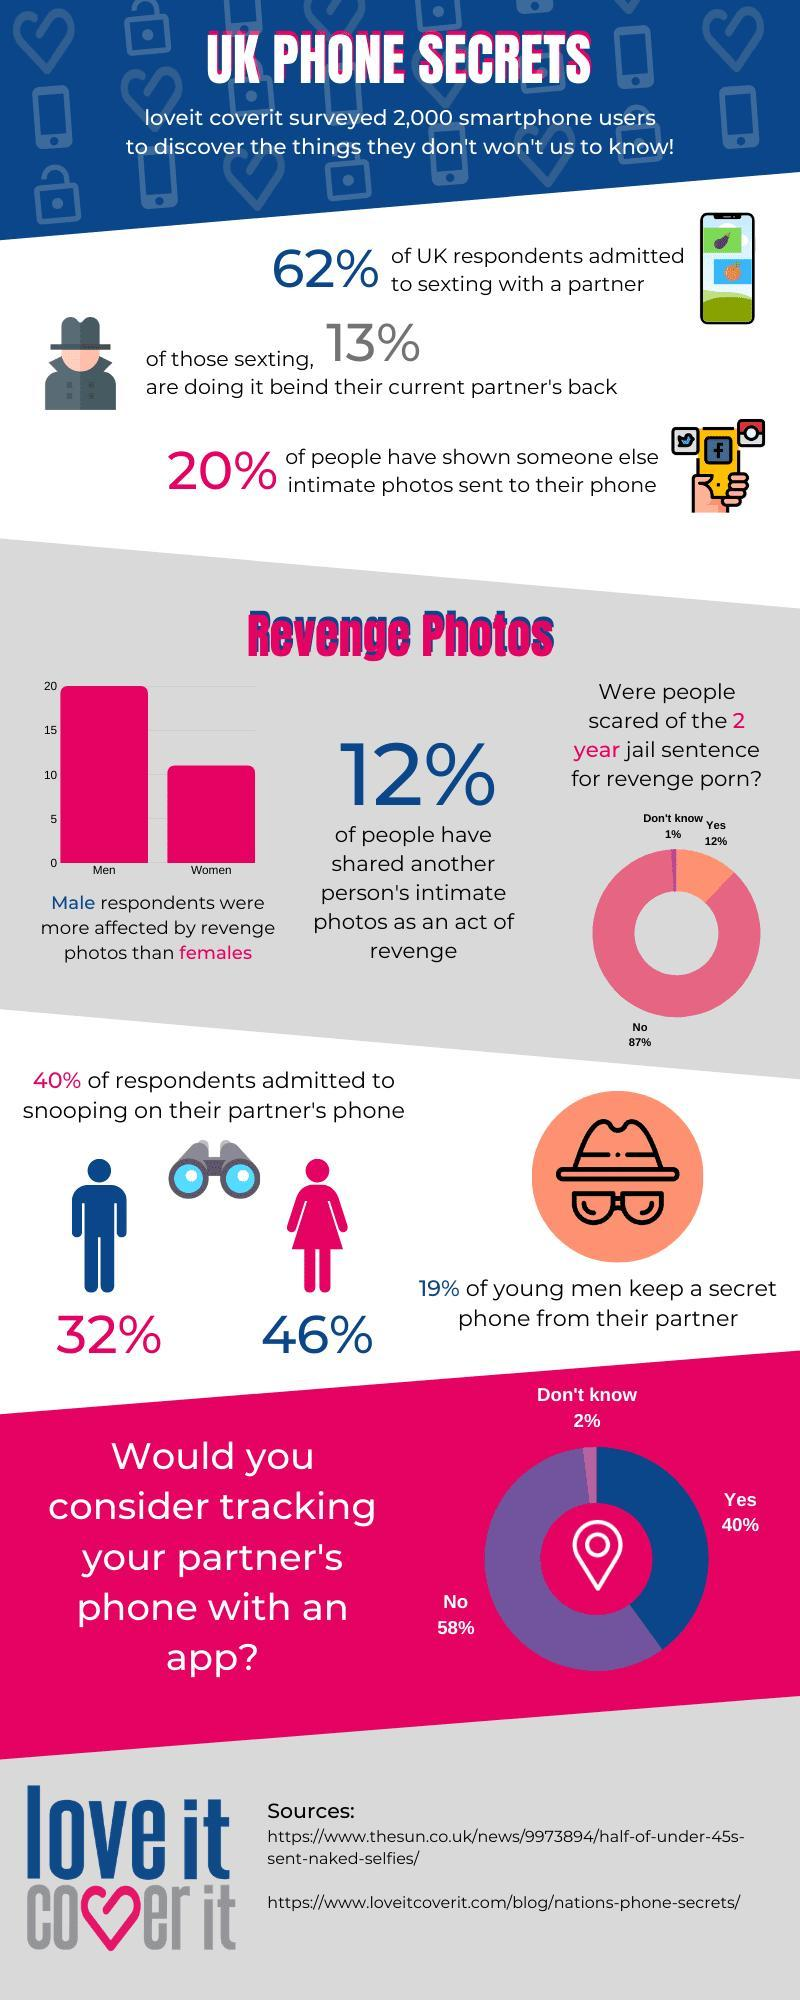By what percent were men more affected than women by revenge photos ?
Answer the question with a short phrase. 50% What percent of the respondents did not keep a secret phone from their partner ? 81% From the 2000 surveyed, how many respondents admitted to to showing someone else intimate photos ? 400 What is the colour given for the image of males here- black, blue or pink ? Blue What percent of people have shared an other persons intimate photos an act of revenge? 12% What percent of people are not sure whether they would track their partners phone with an app ? 2% How many respondents participated in this study ? 2000 What percent of  UK citizens admitted to sexting someone else other than their own partner ? 13% What is the term of imprisonment abated for indulging in revenge porn? 2 years What percent of women admitted to snooping on their partners phone? 46% 